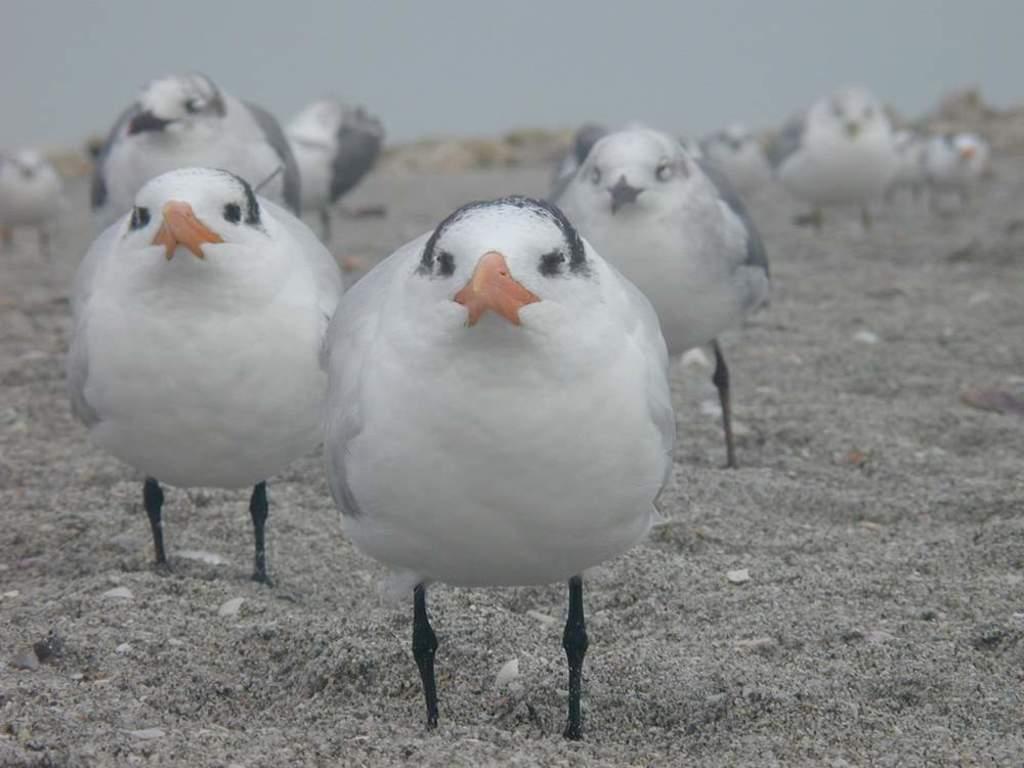How would you summarize this image in a sentence or two? In this image we can see a few birds on the ground and in the background we can see the sky. 